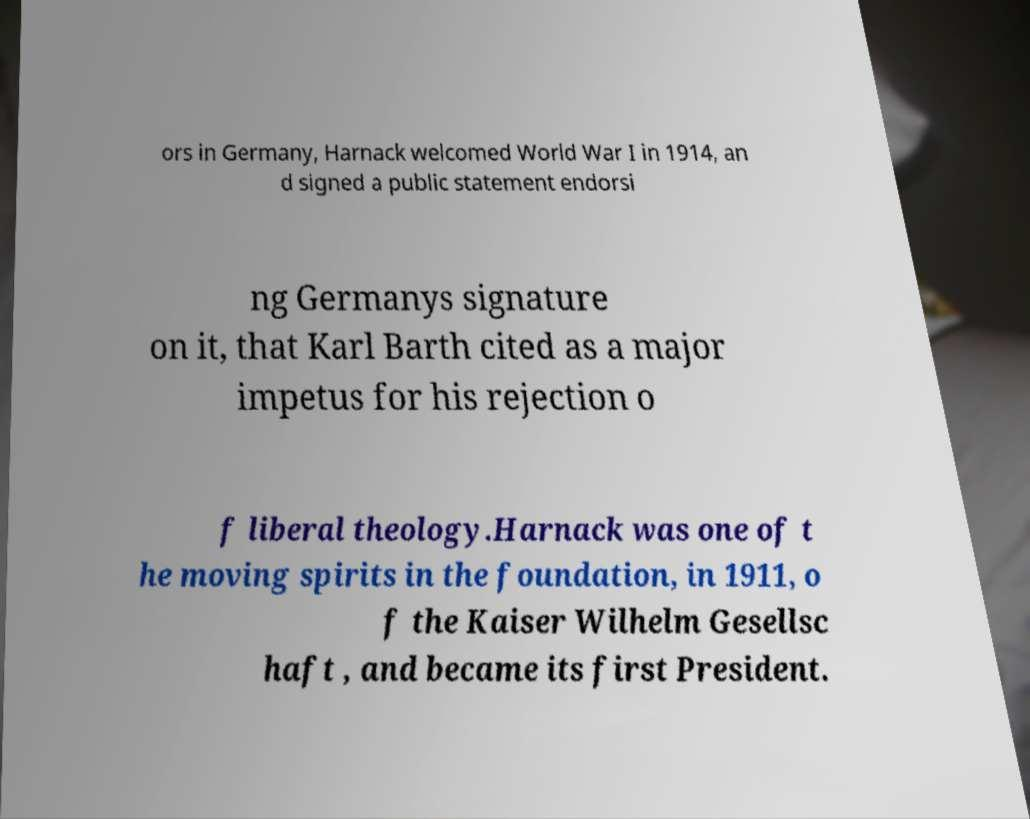There's text embedded in this image that I need extracted. Can you transcribe it verbatim? ors in Germany, Harnack welcomed World War I in 1914, an d signed a public statement endorsi ng Germanys signature on it, that Karl Barth cited as a major impetus for his rejection o f liberal theology.Harnack was one of t he moving spirits in the foundation, in 1911, o f the Kaiser Wilhelm Gesellsc haft , and became its first President. 